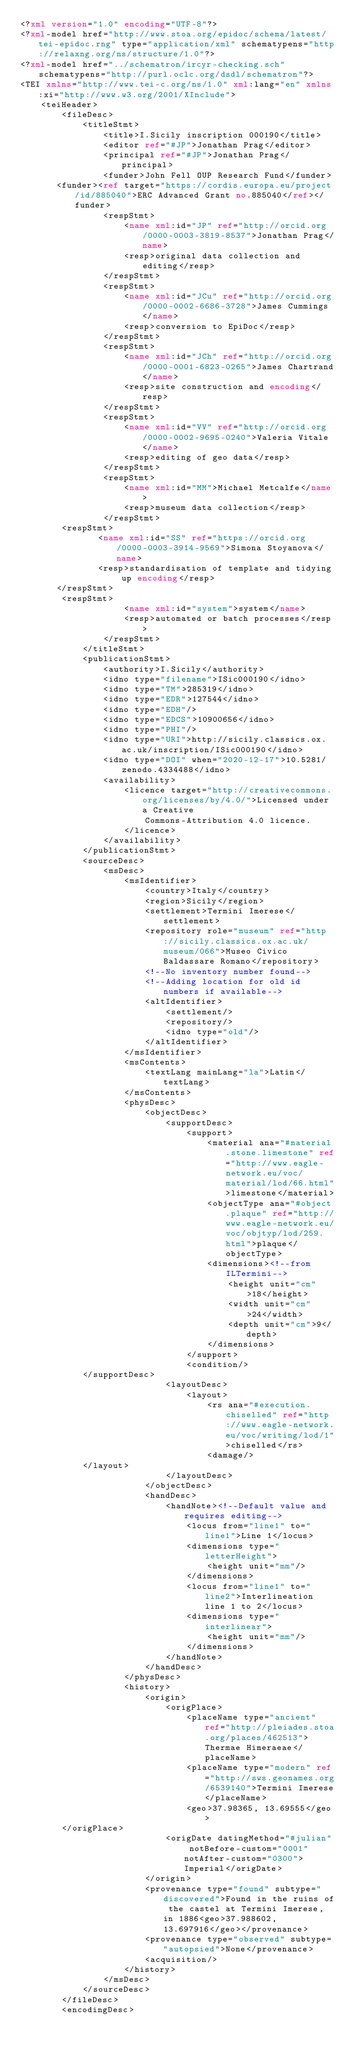Convert code to text. <code><loc_0><loc_0><loc_500><loc_500><_XML_><?xml version="1.0" encoding="UTF-8"?>
<?xml-model href="http://www.stoa.org/epidoc/schema/latest/tei-epidoc.rng" type="application/xml" schematypens="http://relaxng.org/ns/structure/1.0"?>
<?xml-model href="../schematron/ircyr-checking.sch" schematypens="http://purl.oclc.org/dsdl/schematron"?>                                                
<TEI xmlns="http://www.tei-c.org/ns/1.0" xml:lang="en" xmlns:xi="http://www.w3.org/2001/XInclude">
    <teiHeader>
        <fileDesc>
            <titleStmt>
                <title>I.Sicily inscription 000190</title>
                <editor ref="#JP">Jonathan Prag</editor>
                <principal ref="#JP">Jonathan Prag</principal>
                <funder>John Fell OUP Research Fund</funder>
	   <funder><ref target="https://cordis.europa.eu/project/id/885040">ERC Advanced Grant no.885040</ref></funder>
                <respStmt>
                    <name xml:id="JP" ref="http://orcid.org/0000-0003-3819-8537">Jonathan Prag</name>
                    <resp>original data collection and editing</resp>
                </respStmt>
                <respStmt>
                    <name xml:id="JCu" ref="http://orcid.org/0000-0002-6686-3728">James Cummings</name>
                    <resp>conversion to EpiDoc</resp>
                </respStmt>
                <respStmt>
                    <name xml:id="JCh" ref="http://orcid.org/0000-0001-6823-0265">James Chartrand</name>
                    <resp>site construction and encoding</resp>
                </respStmt>
                <respStmt>
                    <name xml:id="VV" ref="http://orcid.org/0000-0002-9695-0240">Valeria Vitale</name>
                    <resp>editing of geo data</resp>
                </respStmt>
                <respStmt>
                    <name xml:id="MM">Michael Metcalfe</name>
                    <resp>museum data collection</resp>
                </respStmt>
	    <respStmt>
     	       <name xml:id="SS" ref="https://orcid.org/0000-0003-3914-9569">Simona Stoyanova</name>
     	       <resp>standardisation of template and tidying up encoding</resp>
 	   </respStmt>
	    <respStmt>
                    <name xml:id="system">system</name>
                    <resp>automated or batch processes</resp>
                </respStmt>
            </titleStmt>
            <publicationStmt>
                <authority>I.Sicily</authority>
                <idno type="filename">ISic000190</idno>
                <idno type="TM">285319</idno>
                <idno type="EDR">127544</idno>
                <idno type="EDH"/>
                <idno type="EDCS">10900656</idno>
                <idno type="PHI"/>
                <idno type="URI">http://sicily.classics.ox.ac.uk/inscription/ISic000190</idno>
                <idno type="DOI" when="2020-12-17">10.5281/zenodo.4334488</idno>
                <availability>
                    <licence target="http://creativecommons.org/licenses/by/4.0/">Licensed under a Creative
                        Commons-Attribution 4.0 licence.
                    </licence>
                </availability>
            </publicationStmt>
            <sourceDesc>
                <msDesc>
                    <msIdentifier>
                        <country>Italy</country>
                        <region>Sicily</region>
                        <settlement>Termini Imerese</settlement>
                        <repository role="museum" ref="http://sicily.classics.ox.ac.uk/museum/066">Museo Civico Baldassare Romano</repository>
                        <!--No inventory number found-->
                        <!--Adding location for old id numbers if available-->
                        <altIdentifier>
                            <settlement/>
                            <repository/>
                            <idno type="old"/>
                        </altIdentifier>
                    </msIdentifier>
                    <msContents>
                        <textLang mainLang="la">Latin</textLang>
                    </msContents>
                    <physDesc>
                        <objectDesc>
                            <supportDesc>
                                <support>
                                    <material ana="#material.stone.limestone" ref="http://www.eagle-network.eu/voc/material/lod/66.html">limestone</material>
                                    <objectType ana="#object.plaque" ref="http://www.eagle-network.eu/voc/objtyp/lod/259.html">plaque</objectType>
                                    <dimensions><!--from ILTermini-->
                                        <height unit="cm">18</height>
                                        <width unit="cm">24</width>
                                        <depth unit="cm">9</depth>
                                    </dimensions>
                                </support>
                                <condition/>
		    </supportDesc>
                            <layoutDesc>
                                <layout>
                                    <rs ana="#execution.chiselled" ref="http://www.eagle-network.eu/voc/writing/lod/1">chiselled</rs>
                                	<damage/>
			</layout>
                            </layoutDesc>
                        </objectDesc>
                        <handDesc>
                            <handNote><!--Default value and requires editing-->
                                <locus from="line1" to="line1">Line 1</locus>
                                <dimensions type="letterHeight">
                                    <height unit="mm"/>
                                </dimensions>
                                <locus from="line1" to="line2">Interlineation line 1 to 2</locus>
                                <dimensions type="interlinear">
                                    <height unit="mm"/>
                                </dimensions>
                            </handNote>
                        </handDesc>
                    </physDesc>
                    <history>
                        <origin>
                            <origPlace>
                                <placeName type="ancient" ref="http://pleiades.stoa.org/places/462513">Thermae Himeraeae</placeName>		
                                <placeName type="modern" ref="http://sws.geonames.org/6539140">Termini Imerese</placeName>
                            	<geo>37.98365, 13.69555</geo>
		</origPlace>
                            <origDate datingMethod="#julian" notBefore-custom="0001" notAfter-custom="0300">Imperial</origDate>
                        </origin>
                        <provenance type="found" subtype="discovered">Found in the ruins of the castel at Termini Imerese, in 1886<geo>37.988602, 13.697916</geo></provenance>
                        <provenance type="observed" subtype="autopsied">None</provenance>
                        <acquisition/>
                    </history>
                </msDesc>
            </sourceDesc>
        </fileDesc>
        <encodingDesc></code> 